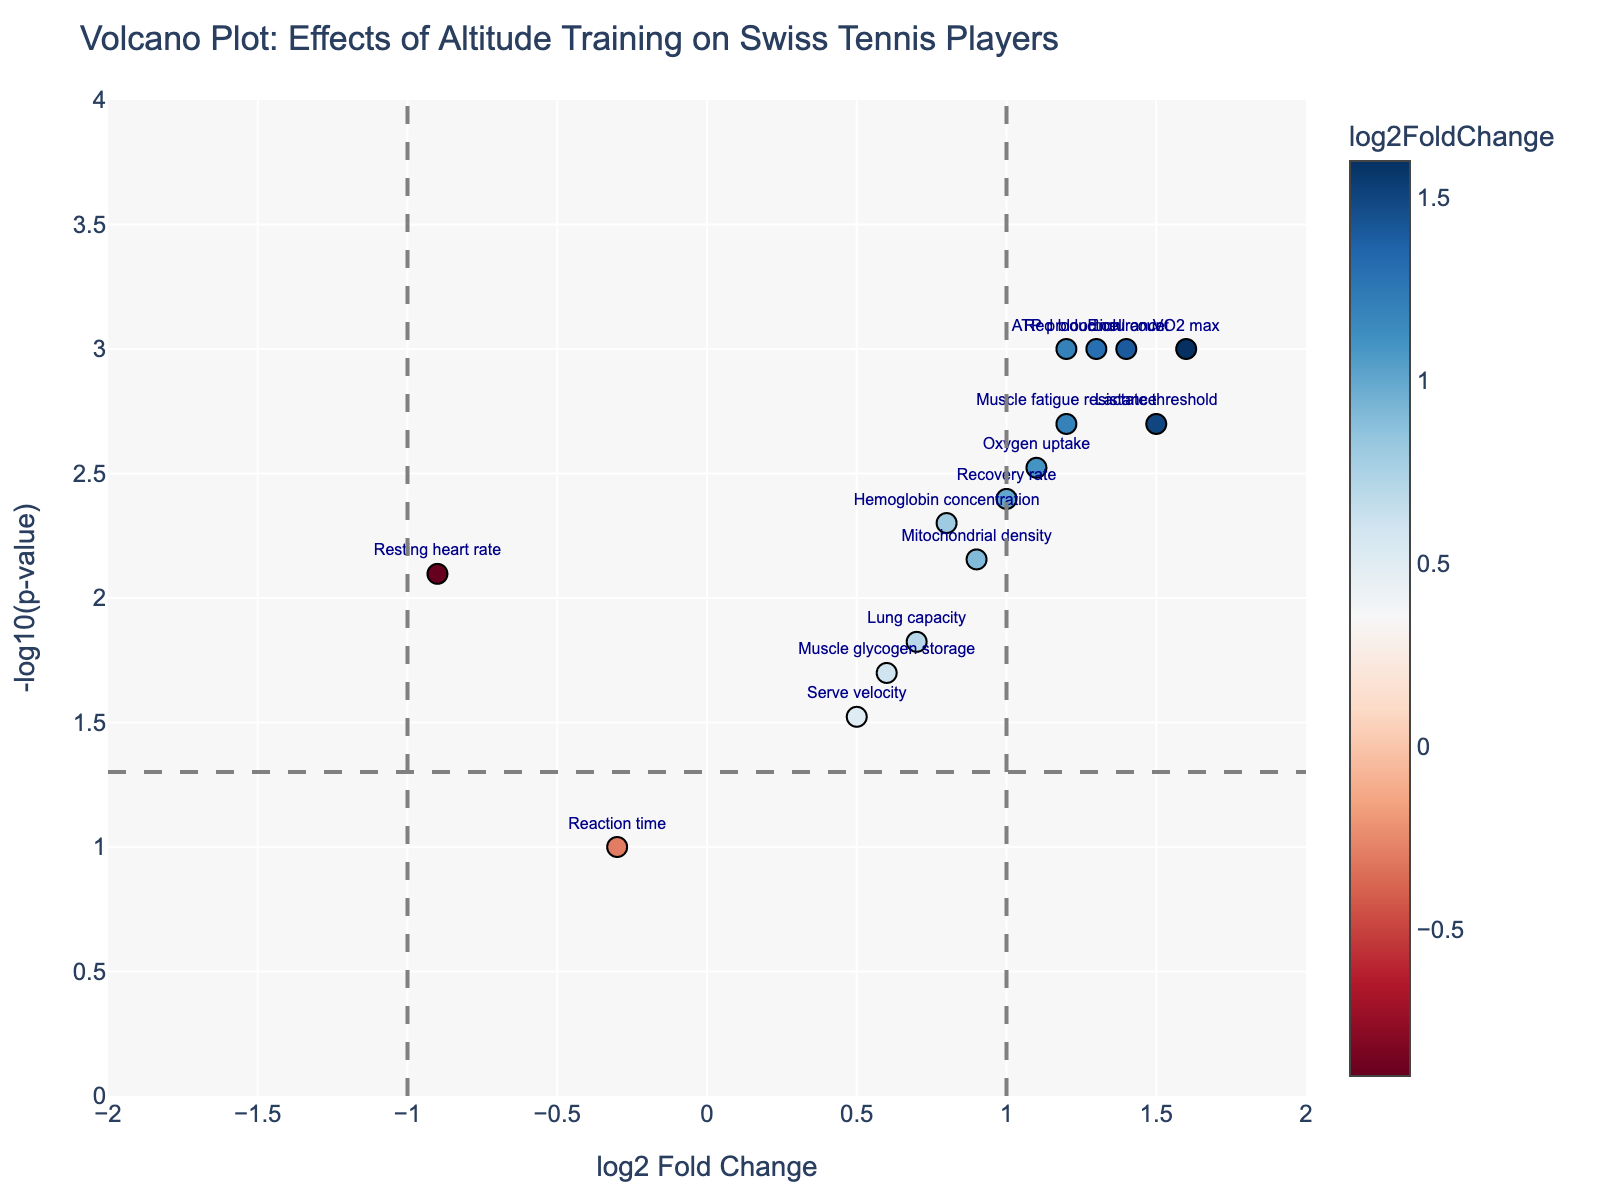Which performance metric shows the greatest log2 fold change? To find the performance metric with the greatest log2 fold change, look for the data point located farthest to the right on the x-axis. This point is associated with the metric labeled "VO2 max," which has a log2FoldChange of 1.6, the highest among all metrics.
Answer: VO2 max Which performance metric has the smallest p-value? Look for the highest point on the vertical axis, since a higher -log10(p-value) corresponds to a smaller p-value. The "VO2 max" metric is the highest on the y-axis with a -log10(pvalue) of 3, indicating a p-value of 0.001, the smallest in the dataset.
Answer: VO2 max What are the performance metrics with negative log2 fold changes? Identify the points located to the left of the vertical line at log2FoldChange = 0. The metrics "Resting heart rate" and "Reaction time" have negative log2 fold changes.
Answer: Resting heart rate and Reaction time How many performance metrics are statistically significant at a p-value threshold of 0.05? The significance threshold is depicted by a horizontal line at -log10(0.05) ≈ 1.3. Count the number of points above this line. There are 12 points above this line, indicating they are statistically significant.
Answer: 12 Which performance metric shows an increase in log2 fold change but is not statistically significant? Look for points on the right side of the graph (positive log2FoldChange) but below the horizontal significance line at -log10(0.05). The metric "Serve velocity" is one such point.
Answer: Serve velocity Among the performance metrics with a log2 fold change greater than 1, which has the highest p-value? Focus on the points to the right of the vertical line at log2FoldChange = 1 and check which one is lowest on the y-axis. "Endurance" has a log2 fold change of 1.4 and a p-value of 0.001. Any other metric with a log2 fold change greater than 1 but lower on the y-axis, like "Mitochondrial density," would not apply since we seek the highest p-value.
Answer: Endurance Is there any performance metric with a log2 fold change of zero? To check for a log2 fold change of zero, look for a point at the intersection of the vertical axis at log2FoldChange = 0. There is no performance metric exactly at this intersection in the plot.
Answer: No Which performance metric shows the greatest statistical significance (smallest p-value) without any change in log2 fold change? For no change in log2 fold change, focus around log2FoldChange = 0 and check the highest on the vertical y-axis; however, no metrics sit exactly at zero log2FoldChange, so no metric fits this criterion.
Answer: None Which metrics show both a log2 fold change greater than 1 and a -log10(p-value) greater than 2? Look to the right of the vertical line at log2FoldChange = 1 and above the horizontal line at -log10(p-value) = 2. The performance metrics are "Lactate threshold," "VO2 max," "Endurance," and "Red blood cell count."
Answer: Lactate threshold, VO2 max, Endurance, and Red blood cell count 